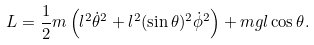<formula> <loc_0><loc_0><loc_500><loc_500>L = \frac { 1 } { 2 } m \left ( l ^ { 2 } { \dot { \theta } } ^ { 2 } + l ^ { 2 } ( \sin { \theta } ) ^ { 2 } { \dot { \phi } } ^ { 2 } \right ) + m g l \cos { \theta } .</formula> 